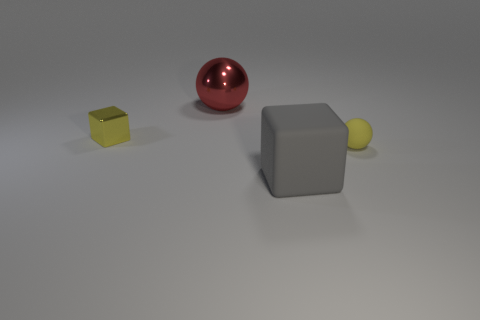Add 3 tiny shiny objects. How many objects exist? 7 Subtract all shiny things. Subtract all large metallic things. How many objects are left? 1 Add 1 big red spheres. How many big red spheres are left? 2 Add 1 cyan cubes. How many cyan cubes exist? 1 Subtract 0 green cubes. How many objects are left? 4 Subtract all cyan cubes. Subtract all gray balls. How many cubes are left? 2 